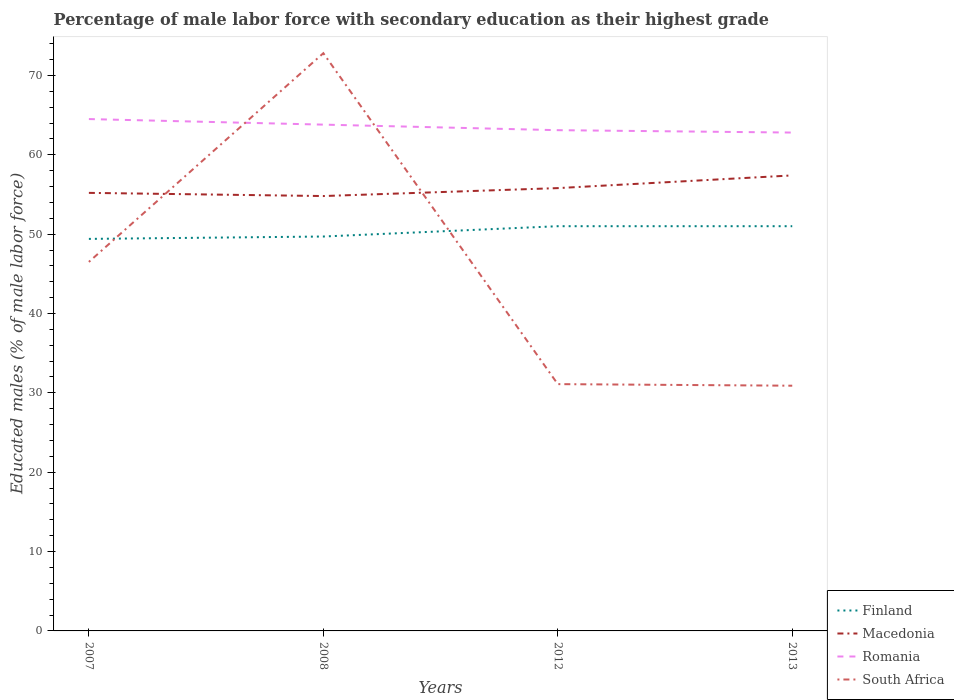How many different coloured lines are there?
Provide a succinct answer. 4. Is the number of lines equal to the number of legend labels?
Your answer should be very brief. Yes. Across all years, what is the maximum percentage of male labor force with secondary education in Romania?
Offer a very short reply. 62.8. In which year was the percentage of male labor force with secondary education in Romania maximum?
Provide a succinct answer. 2013. What is the difference between the highest and the second highest percentage of male labor force with secondary education in Finland?
Your response must be concise. 1.6. What is the difference between the highest and the lowest percentage of male labor force with secondary education in Macedonia?
Your answer should be compact. 1. Is the percentage of male labor force with secondary education in Finland strictly greater than the percentage of male labor force with secondary education in Romania over the years?
Ensure brevity in your answer.  Yes. How are the legend labels stacked?
Provide a short and direct response. Vertical. What is the title of the graph?
Make the answer very short. Percentage of male labor force with secondary education as their highest grade. Does "High income: OECD" appear as one of the legend labels in the graph?
Offer a terse response. No. What is the label or title of the X-axis?
Provide a short and direct response. Years. What is the label or title of the Y-axis?
Your answer should be compact. Educated males (% of male labor force). What is the Educated males (% of male labor force) in Finland in 2007?
Your answer should be compact. 49.4. What is the Educated males (% of male labor force) in Macedonia in 2007?
Ensure brevity in your answer.  55.2. What is the Educated males (% of male labor force) in Romania in 2007?
Your answer should be very brief. 64.5. What is the Educated males (% of male labor force) in South Africa in 2007?
Offer a terse response. 46.5. What is the Educated males (% of male labor force) of Finland in 2008?
Give a very brief answer. 49.7. What is the Educated males (% of male labor force) in Macedonia in 2008?
Give a very brief answer. 54.8. What is the Educated males (% of male labor force) of Romania in 2008?
Offer a terse response. 63.8. What is the Educated males (% of male labor force) in South Africa in 2008?
Give a very brief answer. 72.8. What is the Educated males (% of male labor force) in Macedonia in 2012?
Your answer should be compact. 55.8. What is the Educated males (% of male labor force) in Romania in 2012?
Make the answer very short. 63.1. What is the Educated males (% of male labor force) in South Africa in 2012?
Provide a short and direct response. 31.1. What is the Educated males (% of male labor force) of Macedonia in 2013?
Offer a very short reply. 57.4. What is the Educated males (% of male labor force) in Romania in 2013?
Offer a very short reply. 62.8. What is the Educated males (% of male labor force) of South Africa in 2013?
Provide a short and direct response. 30.9. Across all years, what is the maximum Educated males (% of male labor force) in Macedonia?
Provide a short and direct response. 57.4. Across all years, what is the maximum Educated males (% of male labor force) in Romania?
Ensure brevity in your answer.  64.5. Across all years, what is the maximum Educated males (% of male labor force) of South Africa?
Ensure brevity in your answer.  72.8. Across all years, what is the minimum Educated males (% of male labor force) of Finland?
Your answer should be compact. 49.4. Across all years, what is the minimum Educated males (% of male labor force) of Macedonia?
Provide a succinct answer. 54.8. Across all years, what is the minimum Educated males (% of male labor force) of Romania?
Offer a very short reply. 62.8. Across all years, what is the minimum Educated males (% of male labor force) of South Africa?
Offer a very short reply. 30.9. What is the total Educated males (% of male labor force) in Finland in the graph?
Ensure brevity in your answer.  201.1. What is the total Educated males (% of male labor force) of Macedonia in the graph?
Offer a terse response. 223.2. What is the total Educated males (% of male labor force) of Romania in the graph?
Your response must be concise. 254.2. What is the total Educated males (% of male labor force) in South Africa in the graph?
Make the answer very short. 181.3. What is the difference between the Educated males (% of male labor force) of Finland in 2007 and that in 2008?
Your answer should be very brief. -0.3. What is the difference between the Educated males (% of male labor force) in South Africa in 2007 and that in 2008?
Ensure brevity in your answer.  -26.3. What is the difference between the Educated males (% of male labor force) in Finland in 2007 and that in 2012?
Offer a terse response. -1.6. What is the difference between the Educated males (% of male labor force) in Macedonia in 2007 and that in 2012?
Your answer should be compact. -0.6. What is the difference between the Educated males (% of male labor force) of Finland in 2007 and that in 2013?
Your response must be concise. -1.6. What is the difference between the Educated males (% of male labor force) in Macedonia in 2007 and that in 2013?
Provide a short and direct response. -2.2. What is the difference between the Educated males (% of male labor force) in Romania in 2007 and that in 2013?
Give a very brief answer. 1.7. What is the difference between the Educated males (% of male labor force) in South Africa in 2007 and that in 2013?
Your answer should be very brief. 15.6. What is the difference between the Educated males (% of male labor force) of Finland in 2008 and that in 2012?
Give a very brief answer. -1.3. What is the difference between the Educated males (% of male labor force) in Macedonia in 2008 and that in 2012?
Your answer should be compact. -1. What is the difference between the Educated males (% of male labor force) in Romania in 2008 and that in 2012?
Make the answer very short. 0.7. What is the difference between the Educated males (% of male labor force) of South Africa in 2008 and that in 2012?
Your response must be concise. 41.7. What is the difference between the Educated males (% of male labor force) of Romania in 2008 and that in 2013?
Your answer should be compact. 1. What is the difference between the Educated males (% of male labor force) in South Africa in 2008 and that in 2013?
Provide a short and direct response. 41.9. What is the difference between the Educated males (% of male labor force) of Finland in 2012 and that in 2013?
Make the answer very short. 0. What is the difference between the Educated males (% of male labor force) of Romania in 2012 and that in 2013?
Keep it short and to the point. 0.3. What is the difference between the Educated males (% of male labor force) of South Africa in 2012 and that in 2013?
Give a very brief answer. 0.2. What is the difference between the Educated males (% of male labor force) in Finland in 2007 and the Educated males (% of male labor force) in Macedonia in 2008?
Provide a succinct answer. -5.4. What is the difference between the Educated males (% of male labor force) in Finland in 2007 and the Educated males (% of male labor force) in Romania in 2008?
Make the answer very short. -14.4. What is the difference between the Educated males (% of male labor force) in Finland in 2007 and the Educated males (% of male labor force) in South Africa in 2008?
Offer a terse response. -23.4. What is the difference between the Educated males (% of male labor force) of Macedonia in 2007 and the Educated males (% of male labor force) of Romania in 2008?
Offer a terse response. -8.6. What is the difference between the Educated males (% of male labor force) in Macedonia in 2007 and the Educated males (% of male labor force) in South Africa in 2008?
Ensure brevity in your answer.  -17.6. What is the difference between the Educated males (% of male labor force) in Finland in 2007 and the Educated males (% of male labor force) in Macedonia in 2012?
Give a very brief answer. -6.4. What is the difference between the Educated males (% of male labor force) in Finland in 2007 and the Educated males (% of male labor force) in Romania in 2012?
Keep it short and to the point. -13.7. What is the difference between the Educated males (% of male labor force) in Macedonia in 2007 and the Educated males (% of male labor force) in Romania in 2012?
Offer a very short reply. -7.9. What is the difference between the Educated males (% of male labor force) in Macedonia in 2007 and the Educated males (% of male labor force) in South Africa in 2012?
Provide a short and direct response. 24.1. What is the difference between the Educated males (% of male labor force) of Romania in 2007 and the Educated males (% of male labor force) of South Africa in 2012?
Offer a terse response. 33.4. What is the difference between the Educated males (% of male labor force) in Finland in 2007 and the Educated males (% of male labor force) in Macedonia in 2013?
Provide a succinct answer. -8. What is the difference between the Educated males (% of male labor force) in Finland in 2007 and the Educated males (% of male labor force) in South Africa in 2013?
Give a very brief answer. 18.5. What is the difference between the Educated males (% of male labor force) in Macedonia in 2007 and the Educated males (% of male labor force) in South Africa in 2013?
Ensure brevity in your answer.  24.3. What is the difference between the Educated males (% of male labor force) of Romania in 2007 and the Educated males (% of male labor force) of South Africa in 2013?
Offer a very short reply. 33.6. What is the difference between the Educated males (% of male labor force) of Finland in 2008 and the Educated males (% of male labor force) of Macedonia in 2012?
Your answer should be compact. -6.1. What is the difference between the Educated males (% of male labor force) of Finland in 2008 and the Educated males (% of male labor force) of Romania in 2012?
Your answer should be very brief. -13.4. What is the difference between the Educated males (% of male labor force) of Finland in 2008 and the Educated males (% of male labor force) of South Africa in 2012?
Provide a succinct answer. 18.6. What is the difference between the Educated males (% of male labor force) in Macedonia in 2008 and the Educated males (% of male labor force) in South Africa in 2012?
Keep it short and to the point. 23.7. What is the difference between the Educated males (% of male labor force) of Romania in 2008 and the Educated males (% of male labor force) of South Africa in 2012?
Your answer should be very brief. 32.7. What is the difference between the Educated males (% of male labor force) of Finland in 2008 and the Educated males (% of male labor force) of Macedonia in 2013?
Offer a very short reply. -7.7. What is the difference between the Educated males (% of male labor force) of Finland in 2008 and the Educated males (% of male labor force) of Romania in 2013?
Keep it short and to the point. -13.1. What is the difference between the Educated males (% of male labor force) of Finland in 2008 and the Educated males (% of male labor force) of South Africa in 2013?
Keep it short and to the point. 18.8. What is the difference between the Educated males (% of male labor force) of Macedonia in 2008 and the Educated males (% of male labor force) of South Africa in 2013?
Make the answer very short. 23.9. What is the difference between the Educated males (% of male labor force) in Romania in 2008 and the Educated males (% of male labor force) in South Africa in 2013?
Your answer should be very brief. 32.9. What is the difference between the Educated males (% of male labor force) of Finland in 2012 and the Educated males (% of male labor force) of Macedonia in 2013?
Your answer should be compact. -6.4. What is the difference between the Educated males (% of male labor force) of Finland in 2012 and the Educated males (% of male labor force) of South Africa in 2013?
Give a very brief answer. 20.1. What is the difference between the Educated males (% of male labor force) in Macedonia in 2012 and the Educated males (% of male labor force) in South Africa in 2013?
Provide a short and direct response. 24.9. What is the difference between the Educated males (% of male labor force) in Romania in 2012 and the Educated males (% of male labor force) in South Africa in 2013?
Offer a terse response. 32.2. What is the average Educated males (% of male labor force) of Finland per year?
Your answer should be compact. 50.27. What is the average Educated males (% of male labor force) in Macedonia per year?
Offer a very short reply. 55.8. What is the average Educated males (% of male labor force) in Romania per year?
Your response must be concise. 63.55. What is the average Educated males (% of male labor force) in South Africa per year?
Offer a terse response. 45.33. In the year 2007, what is the difference between the Educated males (% of male labor force) in Finland and Educated males (% of male labor force) in Romania?
Offer a very short reply. -15.1. In the year 2007, what is the difference between the Educated males (% of male labor force) of Macedonia and Educated males (% of male labor force) of Romania?
Your response must be concise. -9.3. In the year 2008, what is the difference between the Educated males (% of male labor force) in Finland and Educated males (% of male labor force) in Romania?
Your answer should be compact. -14.1. In the year 2008, what is the difference between the Educated males (% of male labor force) in Finland and Educated males (% of male labor force) in South Africa?
Make the answer very short. -23.1. In the year 2008, what is the difference between the Educated males (% of male labor force) in Macedonia and Educated males (% of male labor force) in Romania?
Provide a succinct answer. -9. In the year 2008, what is the difference between the Educated males (% of male labor force) in Romania and Educated males (% of male labor force) in South Africa?
Offer a very short reply. -9. In the year 2012, what is the difference between the Educated males (% of male labor force) of Finland and Educated males (% of male labor force) of Romania?
Your answer should be very brief. -12.1. In the year 2012, what is the difference between the Educated males (% of male labor force) in Finland and Educated males (% of male labor force) in South Africa?
Your answer should be very brief. 19.9. In the year 2012, what is the difference between the Educated males (% of male labor force) in Macedonia and Educated males (% of male labor force) in South Africa?
Ensure brevity in your answer.  24.7. In the year 2012, what is the difference between the Educated males (% of male labor force) in Romania and Educated males (% of male labor force) in South Africa?
Give a very brief answer. 32. In the year 2013, what is the difference between the Educated males (% of male labor force) in Finland and Educated males (% of male labor force) in Macedonia?
Your answer should be very brief. -6.4. In the year 2013, what is the difference between the Educated males (% of male labor force) of Finland and Educated males (% of male labor force) of Romania?
Your answer should be very brief. -11.8. In the year 2013, what is the difference between the Educated males (% of male labor force) in Finland and Educated males (% of male labor force) in South Africa?
Provide a short and direct response. 20.1. In the year 2013, what is the difference between the Educated males (% of male labor force) in Macedonia and Educated males (% of male labor force) in South Africa?
Offer a very short reply. 26.5. In the year 2013, what is the difference between the Educated males (% of male labor force) in Romania and Educated males (% of male labor force) in South Africa?
Keep it short and to the point. 31.9. What is the ratio of the Educated males (% of male labor force) of Macedonia in 2007 to that in 2008?
Keep it short and to the point. 1.01. What is the ratio of the Educated males (% of male labor force) of South Africa in 2007 to that in 2008?
Offer a very short reply. 0.64. What is the ratio of the Educated males (% of male labor force) of Finland in 2007 to that in 2012?
Keep it short and to the point. 0.97. What is the ratio of the Educated males (% of male labor force) of Romania in 2007 to that in 2012?
Keep it short and to the point. 1.02. What is the ratio of the Educated males (% of male labor force) of South Africa in 2007 to that in 2012?
Offer a very short reply. 1.5. What is the ratio of the Educated males (% of male labor force) of Finland in 2007 to that in 2013?
Your answer should be compact. 0.97. What is the ratio of the Educated males (% of male labor force) of Macedonia in 2007 to that in 2013?
Offer a very short reply. 0.96. What is the ratio of the Educated males (% of male labor force) in Romania in 2007 to that in 2013?
Keep it short and to the point. 1.03. What is the ratio of the Educated males (% of male labor force) of South Africa in 2007 to that in 2013?
Your answer should be compact. 1.5. What is the ratio of the Educated males (% of male labor force) in Finland in 2008 to that in 2012?
Make the answer very short. 0.97. What is the ratio of the Educated males (% of male labor force) in Macedonia in 2008 to that in 2012?
Your answer should be compact. 0.98. What is the ratio of the Educated males (% of male labor force) of Romania in 2008 to that in 2012?
Provide a short and direct response. 1.01. What is the ratio of the Educated males (% of male labor force) in South Africa in 2008 to that in 2012?
Your response must be concise. 2.34. What is the ratio of the Educated males (% of male labor force) of Finland in 2008 to that in 2013?
Your answer should be very brief. 0.97. What is the ratio of the Educated males (% of male labor force) of Macedonia in 2008 to that in 2013?
Keep it short and to the point. 0.95. What is the ratio of the Educated males (% of male labor force) in Romania in 2008 to that in 2013?
Make the answer very short. 1.02. What is the ratio of the Educated males (% of male labor force) in South Africa in 2008 to that in 2013?
Your response must be concise. 2.36. What is the ratio of the Educated males (% of male labor force) in Finland in 2012 to that in 2013?
Offer a terse response. 1. What is the ratio of the Educated males (% of male labor force) in Macedonia in 2012 to that in 2013?
Keep it short and to the point. 0.97. What is the difference between the highest and the second highest Educated males (% of male labor force) of Romania?
Give a very brief answer. 0.7. What is the difference between the highest and the second highest Educated males (% of male labor force) of South Africa?
Offer a very short reply. 26.3. What is the difference between the highest and the lowest Educated males (% of male labor force) in South Africa?
Your response must be concise. 41.9. 